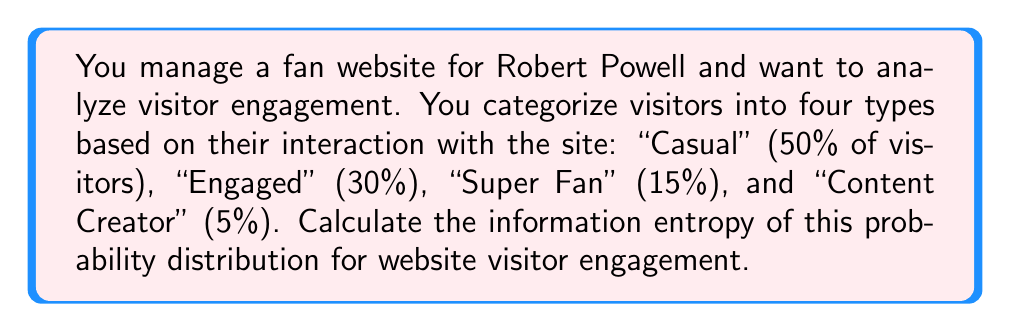Can you solve this math problem? To calculate the information entropy of this probability distribution, we'll use the formula for Shannon entropy:

$$H = -\sum_{i=1}^{n} p_i \log_2(p_i)$$

Where:
- $H$ is the entropy in bits
- $p_i$ is the probability of each outcome
- $n$ is the number of possible outcomes

Let's calculate for each visitor type:

1. Casual: $p_1 = 0.50$
   $-0.50 \log_2(0.50) = 0.5$

2. Engaged: $p_2 = 0.30$
   $-0.30 \log_2(0.30) \approx 0.5211$

3. Super Fan: $p_3 = 0.15$
   $-0.15 \log_2(0.15) \approx 0.4105$

4. Content Creator: $p_4 = 0.05$
   $-0.05 \log_2(0.05) \approx 0.2161$

Now, sum these values:

$$H = 0.5 + 0.5211 + 0.4105 + 0.2161 = 1.6477$$

Therefore, the information entropy of this probability distribution is approximately 1.6477 bits.
Answer: 1.6477 bits 